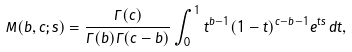Convert formula to latex. <formula><loc_0><loc_0><loc_500><loc_500>M ( b , c ; s ) = \frac { \Gamma ( c ) } { \Gamma ( b ) \Gamma ( c - b ) } \int _ { 0 } ^ { 1 } t ^ { b - 1 } ( 1 - t ) ^ { c - b - 1 } e ^ { t s } \, d t ,</formula> 